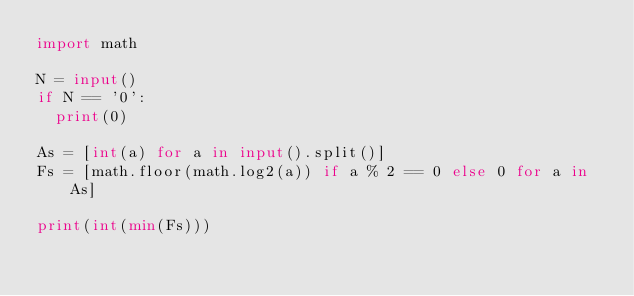Convert code to text. <code><loc_0><loc_0><loc_500><loc_500><_Python_>import math

N = input()
if N == '0':
  print(0)

As = [int(a) for a in input().split()]
Fs = [math.floor(math.log2(a)) if a % 2 == 0 else 0 for a in As]

print(int(min(Fs)))</code> 